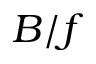<formula> <loc_0><loc_0><loc_500><loc_500>B / f</formula> 